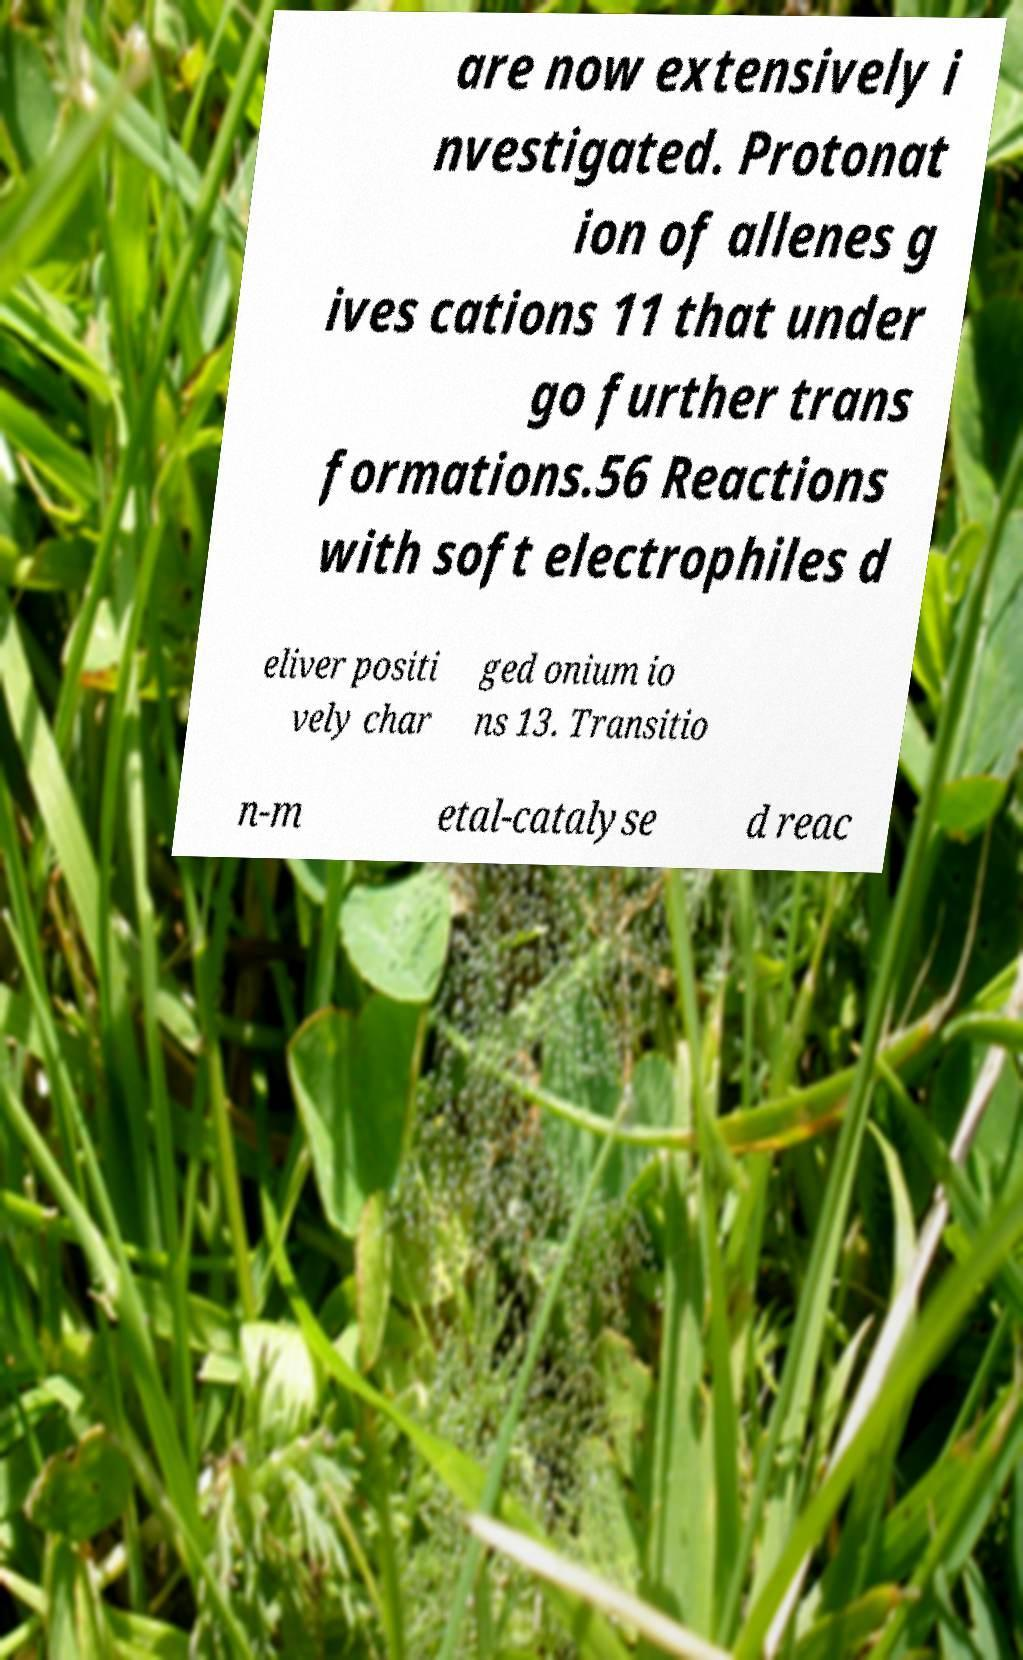I need the written content from this picture converted into text. Can you do that? are now extensively i nvestigated. Protonat ion of allenes g ives cations 11 that under go further trans formations.56 Reactions with soft electrophiles d eliver positi vely char ged onium io ns 13. Transitio n-m etal-catalyse d reac 